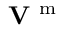Convert formula to latex. <formula><loc_0><loc_0><loc_500><loc_500>{ V } ^ { m }</formula> 